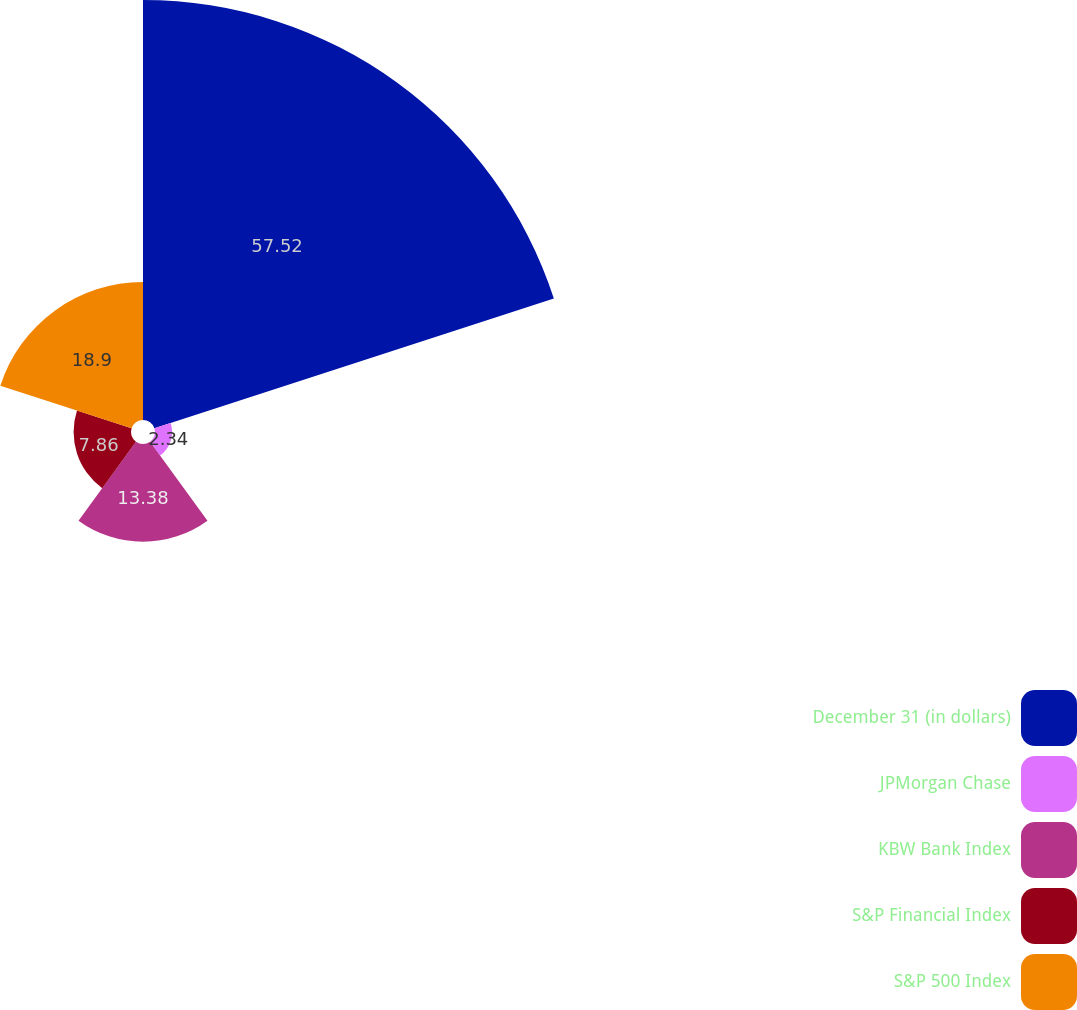<chart> <loc_0><loc_0><loc_500><loc_500><pie_chart><fcel>December 31 (in dollars)<fcel>JPMorgan Chase<fcel>KBW Bank Index<fcel>S&P Financial Index<fcel>S&P 500 Index<nl><fcel>57.52%<fcel>2.34%<fcel>13.38%<fcel>7.86%<fcel>18.9%<nl></chart> 